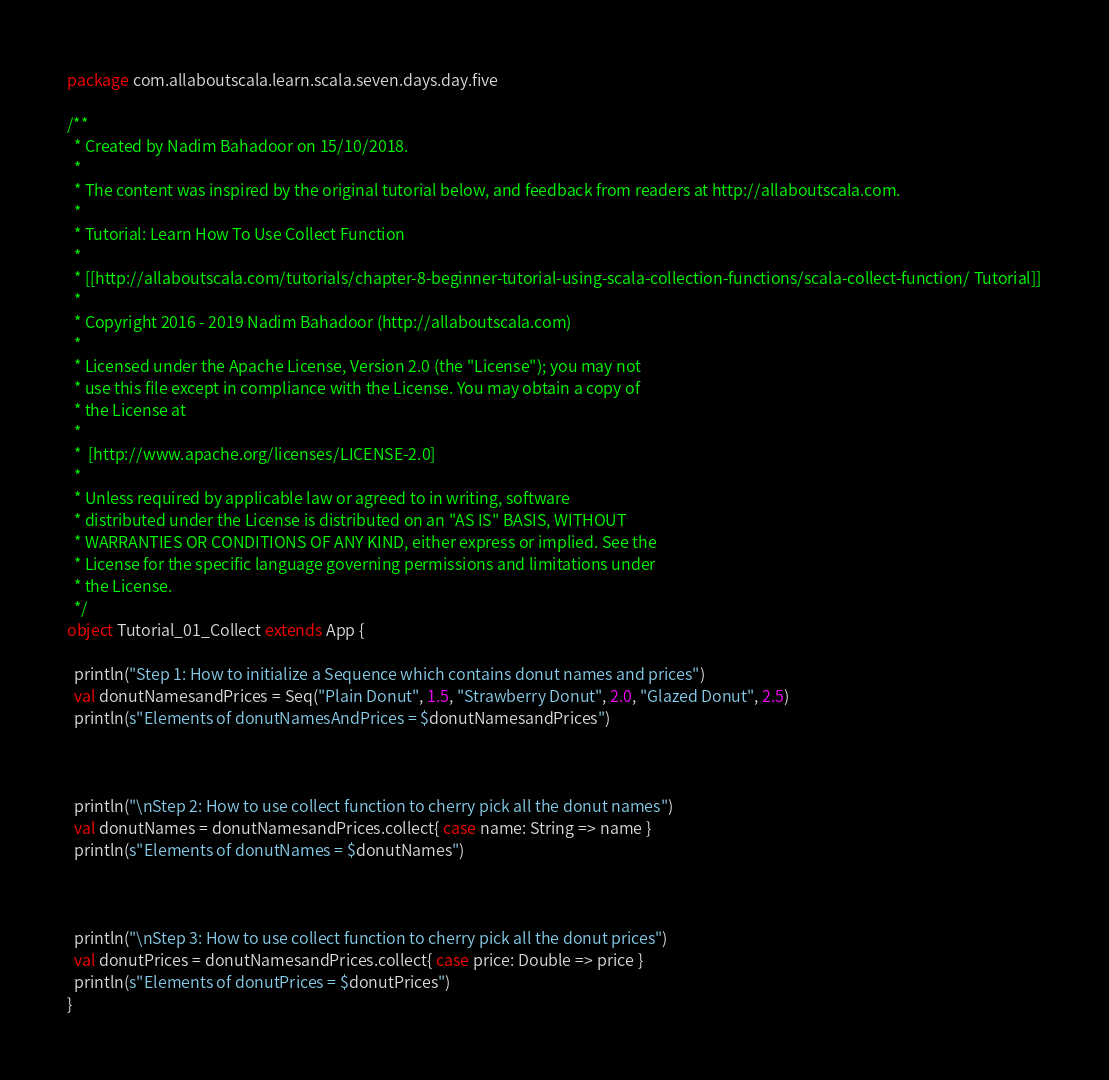<code> <loc_0><loc_0><loc_500><loc_500><_Scala_>package com.allaboutscala.learn.scala.seven.days.day.five

/**
  * Created by Nadim Bahadoor on 15/10/2018.
  *
  * The content was inspired by the original tutorial below, and feedback from readers at http://allaboutscala.com.
  *
  * Tutorial: Learn How To Use Collect Function
  *
  * [[http://allaboutscala.com/tutorials/chapter-8-beginner-tutorial-using-scala-collection-functions/scala-collect-function/ Tutorial]]
  *
  * Copyright 2016 - 2019 Nadim Bahadoor (http://allaboutscala.com)
  *
  * Licensed under the Apache License, Version 2.0 (the "License"); you may not
  * use this file except in compliance with the License. You may obtain a copy of
  * the License at
  *
  *  [http://www.apache.org/licenses/LICENSE-2.0]
  *
  * Unless required by applicable law or agreed to in writing, software
  * distributed under the License is distributed on an "AS IS" BASIS, WITHOUT
  * WARRANTIES OR CONDITIONS OF ANY KIND, either express or implied. See the
  * License for the specific language governing permissions and limitations under
  * the License.
  */
object Tutorial_01_Collect extends App {

  println("Step 1: How to initialize a Sequence which contains donut names and prices")
  val donutNamesandPrices = Seq("Plain Donut", 1.5, "Strawberry Donut", 2.0, "Glazed Donut", 2.5)
  println(s"Elements of donutNamesAndPrices = $donutNamesandPrices")



  println("\nStep 2: How to use collect function to cherry pick all the donut names")
  val donutNames = donutNamesandPrices.collect{ case name: String => name }
  println(s"Elements of donutNames = $donutNames")



  println("\nStep 3: How to use collect function to cherry pick all the donut prices")
  val donutPrices = donutNamesandPrices.collect{ case price: Double => price }
  println(s"Elements of donutPrices = $donutPrices")
}
</code> 